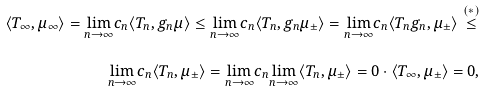Convert formula to latex. <formula><loc_0><loc_0><loc_500><loc_500>\langle T _ { \infty } , \mu _ { \infty } \rangle = \underset { n \to \infty } { \lim } c _ { n } \langle T _ { n } , g _ { n } \mu \rangle \leq \underset { n \to \infty } { \lim } c _ { n } \langle T _ { n } , g _ { n } \mu _ { \pm } \rangle = \underset { n \to \infty } { \lim } c _ { n } \langle T _ { n } g _ { n } , \mu _ { \pm } \rangle \overset { ( \ast ) } { \leq } \\ \underset { n \to \infty } { \lim } c _ { n } \langle T _ { n } , \mu _ { \pm } \rangle = \underset { n \to \infty } { \lim } c _ { n } \underset { n \to \infty } { \lim } \langle T _ { n } , \mu _ { \pm } \rangle = 0 \cdot \langle T _ { \infty } , \mu _ { \pm } \rangle = 0 ,</formula> 